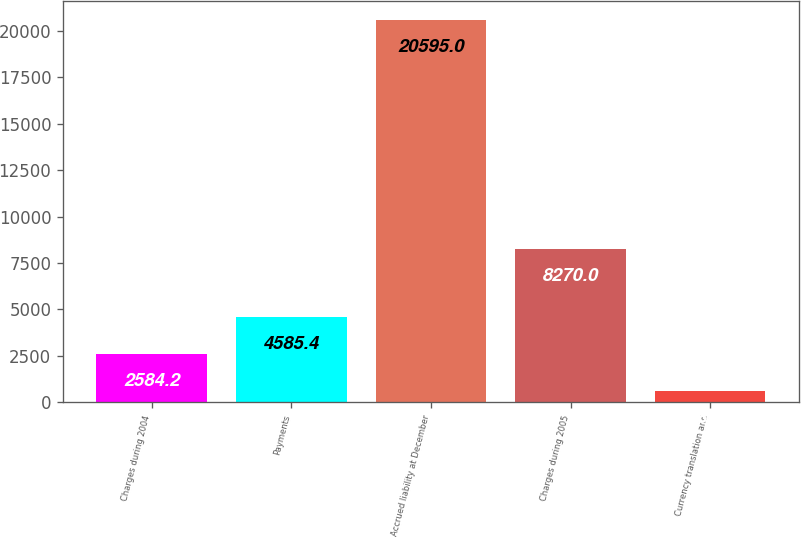Convert chart. <chart><loc_0><loc_0><loc_500><loc_500><bar_chart><fcel>Charges during 2004<fcel>Payments<fcel>Accrued liability at December<fcel>Charges during 2005<fcel>Currency translation and<nl><fcel>2584.2<fcel>4585.4<fcel>20595<fcel>8270<fcel>583<nl></chart> 